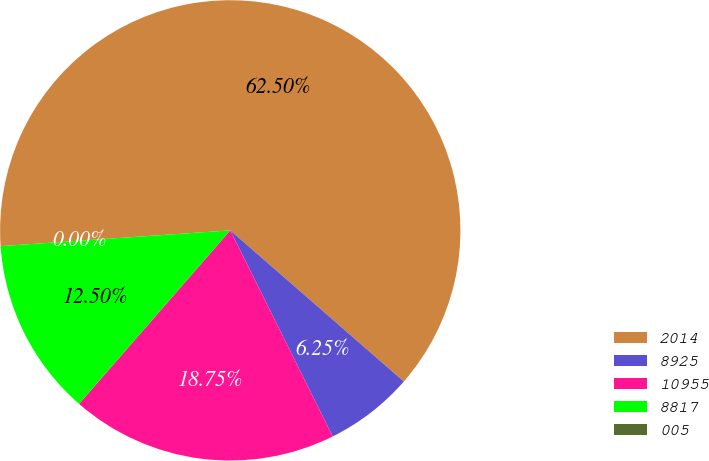Convert chart to OTSL. <chart><loc_0><loc_0><loc_500><loc_500><pie_chart><fcel>2014<fcel>8925<fcel>10955<fcel>8817<fcel>005<nl><fcel>62.49%<fcel>6.25%<fcel>18.75%<fcel>12.5%<fcel>0.0%<nl></chart> 